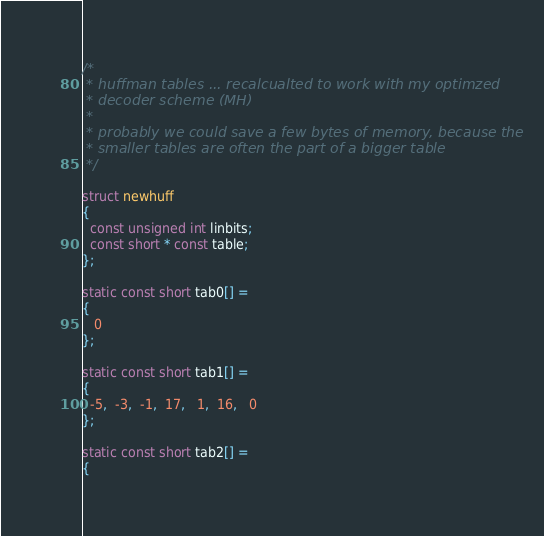Convert code to text. <code><loc_0><loc_0><loc_500><loc_500><_C_>/*
 * huffman tables ... recalcualted to work with my optimzed
 * decoder scheme (MH)
 * 
 * probably we could save a few bytes of memory, because the 
 * smaller tables are often the part of a bigger table
 */

struct newhuff 
{
  const unsigned int linbits;
  const short * const table;
};

static const short tab0[] = 
{ 
   0
};

static const short tab1[] =
{
  -5,  -3,  -1,  17,   1,  16,   0
};

static const short tab2[] =
{</code> 